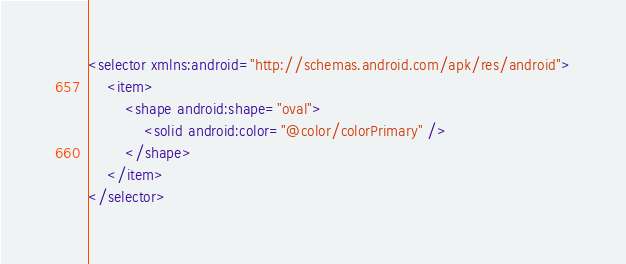<code> <loc_0><loc_0><loc_500><loc_500><_XML_><selector xmlns:android="http://schemas.android.com/apk/res/android">
    <item>
        <shape android:shape="oval">
            <solid android:color="@color/colorPrimary" />
        </shape>
    </item>
</selector></code> 